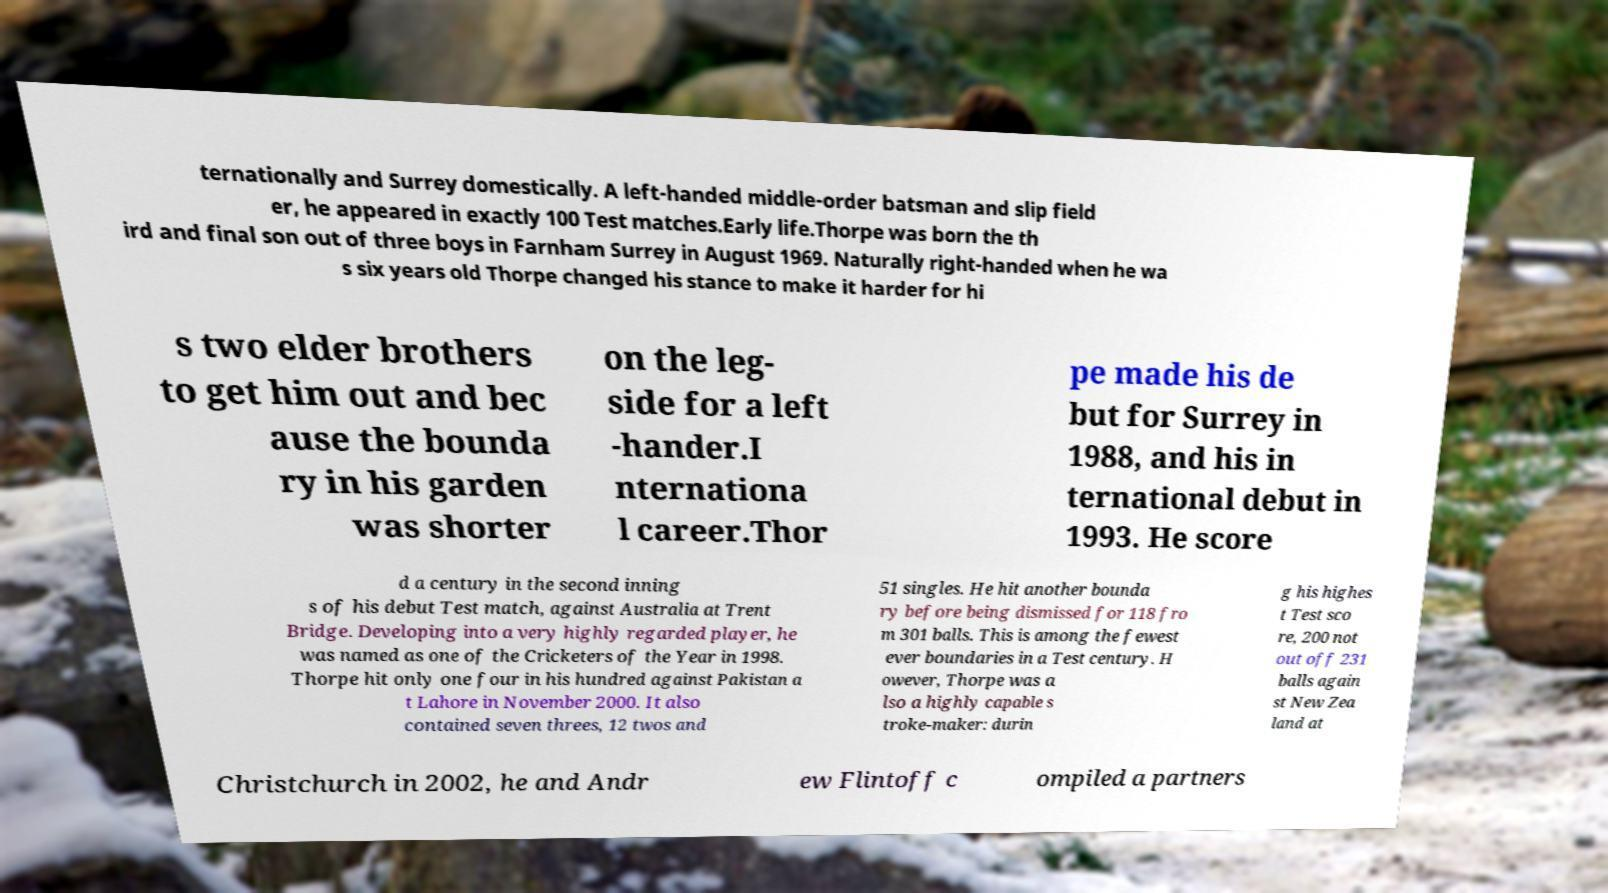There's text embedded in this image that I need extracted. Can you transcribe it verbatim? ternationally and Surrey domestically. A left-handed middle-order batsman and slip field er, he appeared in exactly 100 Test matches.Early life.Thorpe was born the th ird and final son out of three boys in Farnham Surrey in August 1969. Naturally right-handed when he wa s six years old Thorpe changed his stance to make it harder for hi s two elder brothers to get him out and bec ause the bounda ry in his garden was shorter on the leg- side for a left -hander.I nternationa l career.Thor pe made his de but for Surrey in 1988, and his in ternational debut in 1993. He score d a century in the second inning s of his debut Test match, against Australia at Trent Bridge. Developing into a very highly regarded player, he was named as one of the Cricketers of the Year in 1998. Thorpe hit only one four in his hundred against Pakistan a t Lahore in November 2000. It also contained seven threes, 12 twos and 51 singles. He hit another bounda ry before being dismissed for 118 fro m 301 balls. This is among the fewest ever boundaries in a Test century. H owever, Thorpe was a lso a highly capable s troke-maker: durin g his highes t Test sco re, 200 not out off 231 balls again st New Zea land at Christchurch in 2002, he and Andr ew Flintoff c ompiled a partners 